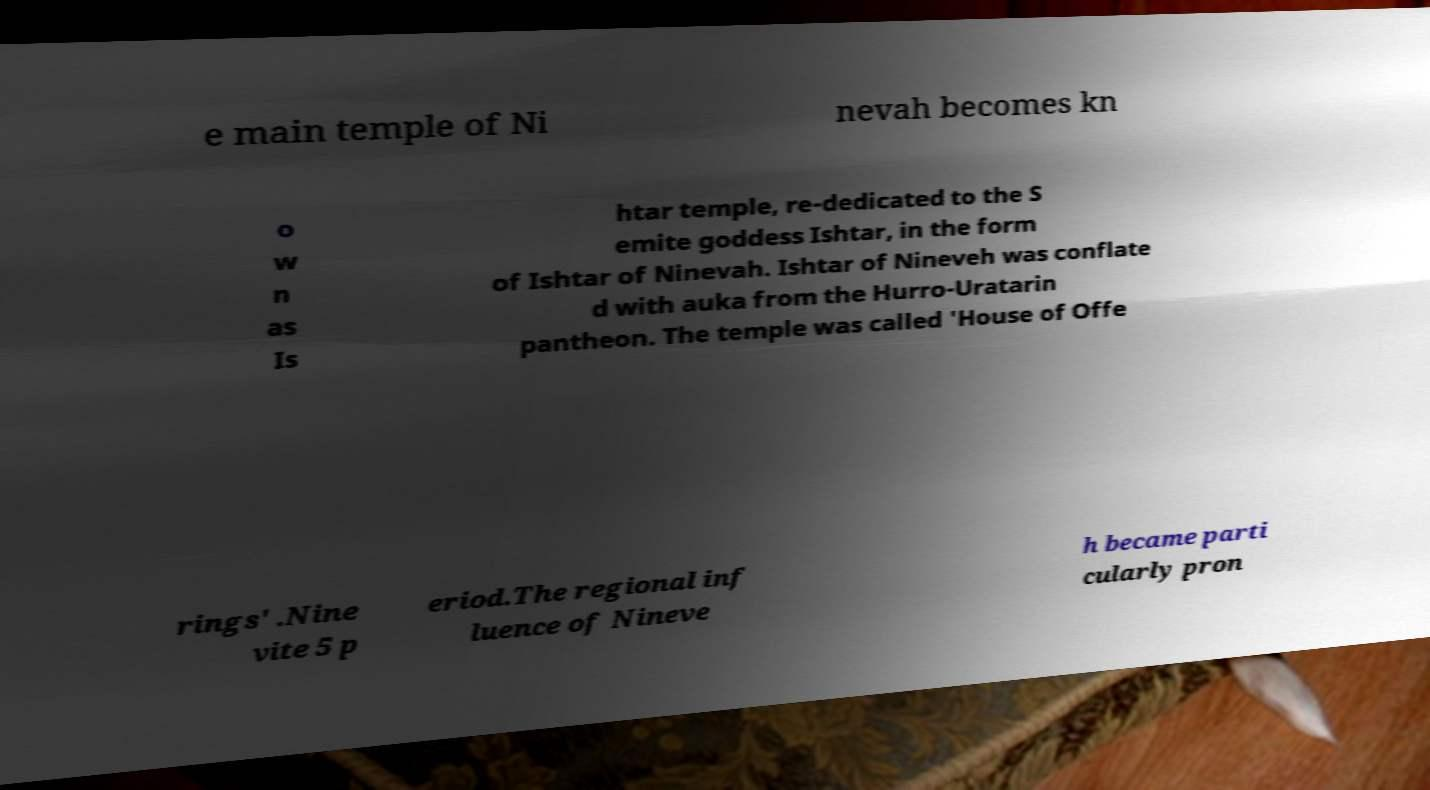Could you extract and type out the text from this image? e main temple of Ni nevah becomes kn o w n as Is htar temple, re-dedicated to the S emite goddess Ishtar, in the form of Ishtar of Ninevah. Ishtar of Nineveh was conflate d with auka from the Hurro-Uratarin pantheon. The temple was called 'House of Offe rings' .Nine vite 5 p eriod.The regional inf luence of Nineve h became parti cularly pron 